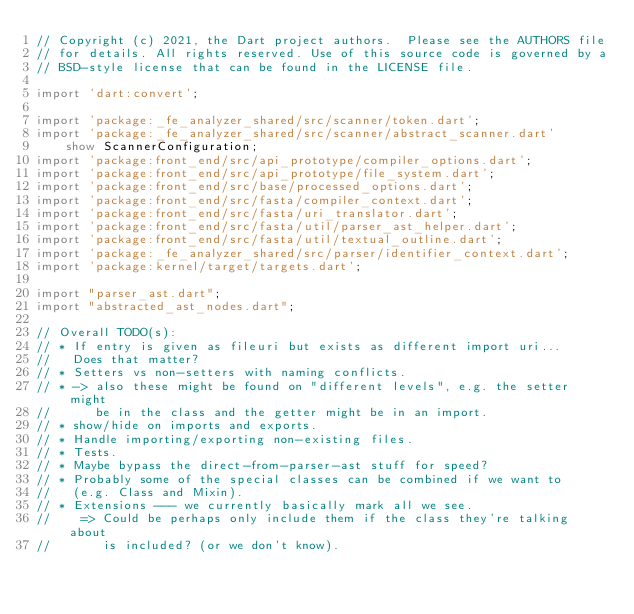<code> <loc_0><loc_0><loc_500><loc_500><_Dart_>// Copyright (c) 2021, the Dart project authors.  Please see the AUTHORS file
// for details. All rights reserved. Use of this source code is governed by a
// BSD-style license that can be found in the LICENSE file.

import 'dart:convert';

import 'package:_fe_analyzer_shared/src/scanner/token.dart';
import 'package:_fe_analyzer_shared/src/scanner/abstract_scanner.dart'
    show ScannerConfiguration;
import 'package:front_end/src/api_prototype/compiler_options.dart';
import 'package:front_end/src/api_prototype/file_system.dart';
import 'package:front_end/src/base/processed_options.dart';
import 'package:front_end/src/fasta/compiler_context.dart';
import 'package:front_end/src/fasta/uri_translator.dart';
import 'package:front_end/src/fasta/util/parser_ast_helper.dart';
import 'package:front_end/src/fasta/util/textual_outline.dart';
import 'package:_fe_analyzer_shared/src/parser/identifier_context.dart';
import 'package:kernel/target/targets.dart';

import "parser_ast.dart";
import "abstracted_ast_nodes.dart";

// Overall TODO(s):
// * If entry is given as fileuri but exists as different import uri...
//   Does that matter?
// * Setters vs non-setters with naming conflicts.
// * -> also these might be found on "different levels", e.g. the setter might
//      be in the class and the getter might be in an import.
// * show/hide on imports and exports.
// * Handle importing/exporting non-existing files.
// * Tests.
// * Maybe bypass the direct-from-parser-ast stuff for speed?
// * Probably some of the special classes can be combined if we want to
//   (e.g. Class and Mixin).
// * Extensions --- we currently basically mark all we see.
//    => Could be perhaps only include them if the class they're talking about
//       is included? (or we don't know).</code> 